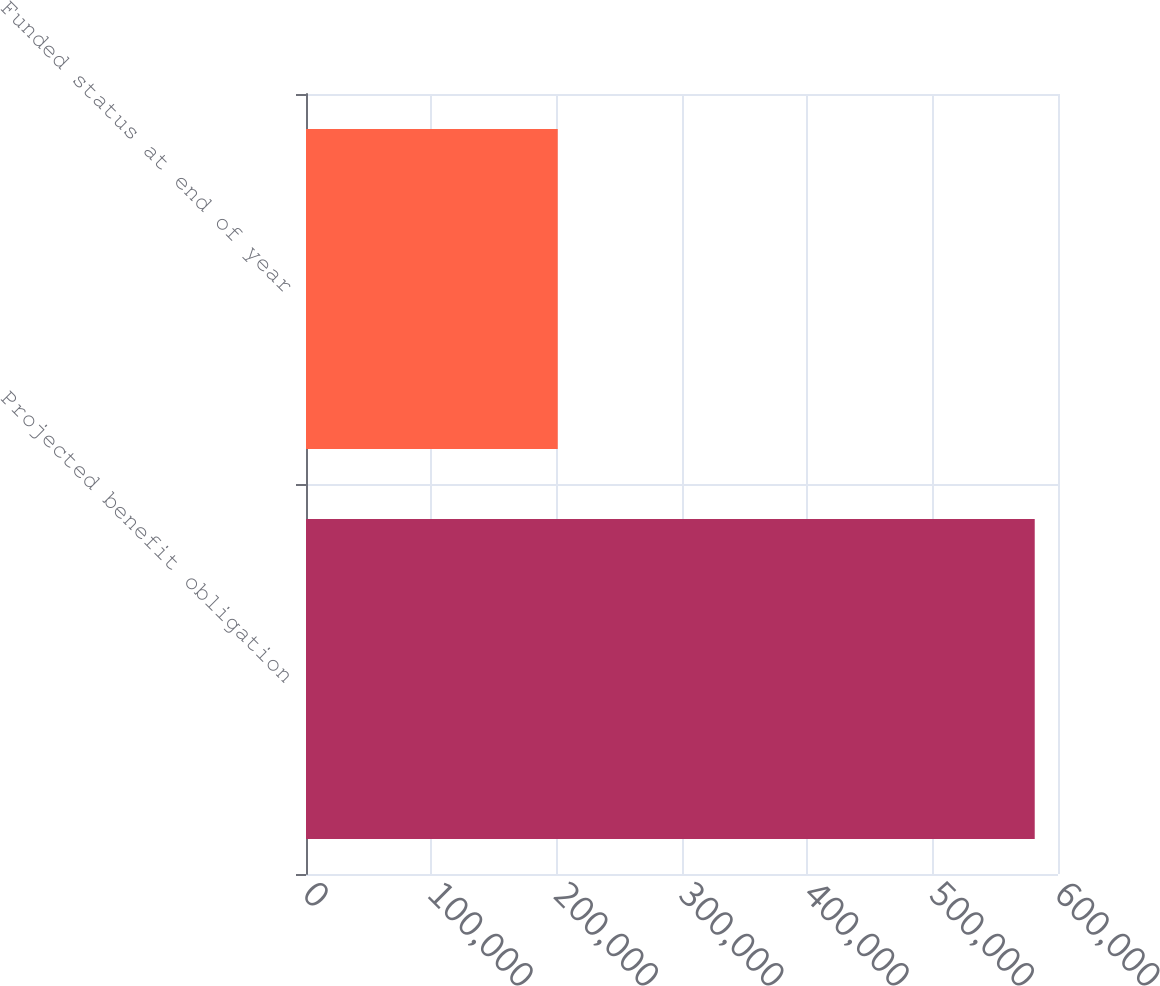Convert chart to OTSL. <chart><loc_0><loc_0><loc_500><loc_500><bar_chart><fcel>Projected benefit obligation<fcel>Funded status at end of year<nl><fcel>581432<fcel>200855<nl></chart> 